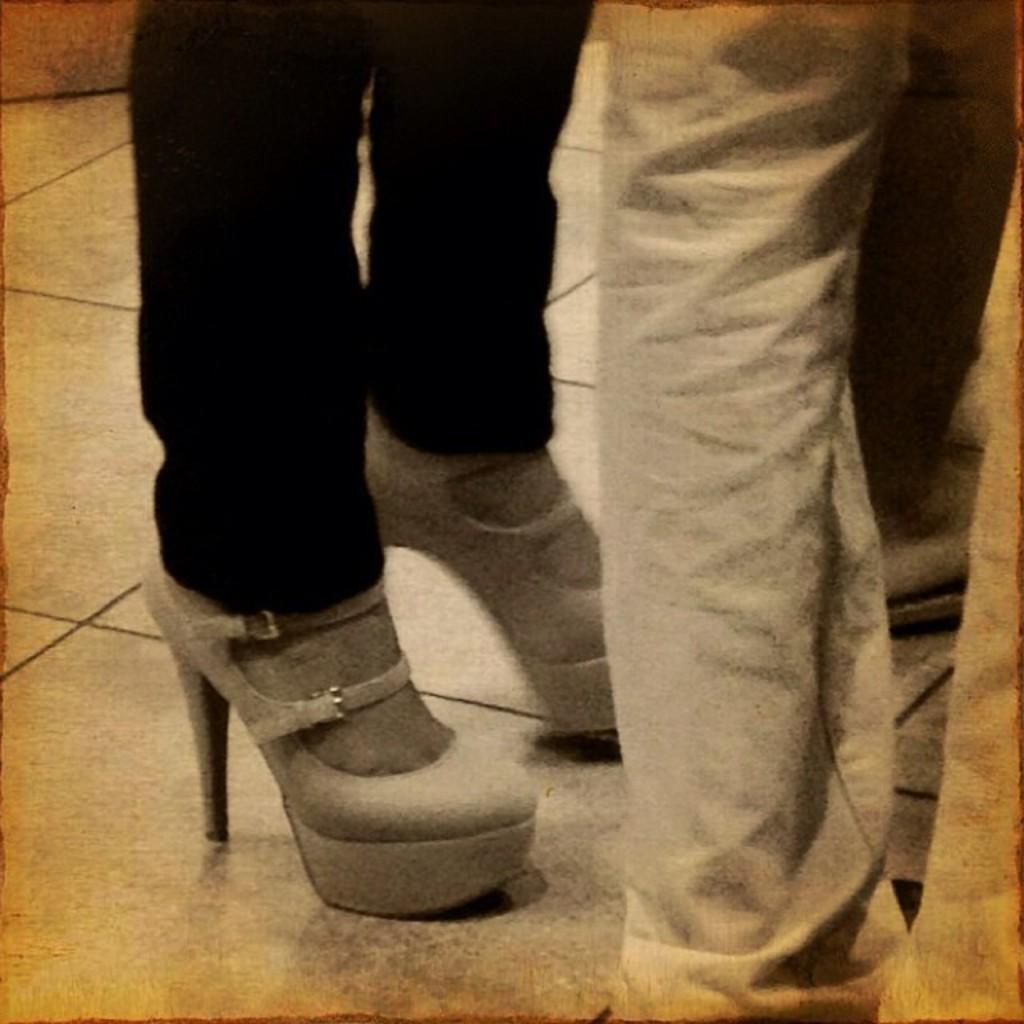How would you summarize this image in a sentence or two? In this image we can see the legs of few people. We can see the footwear of a person. 